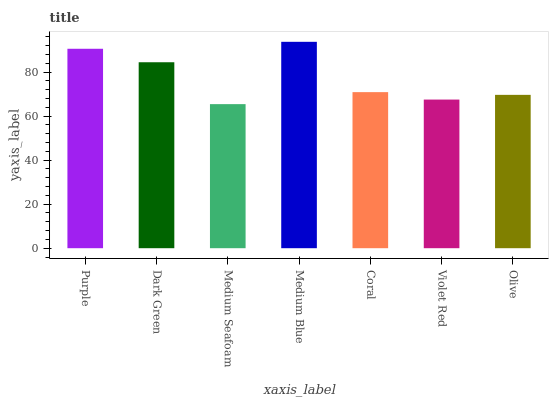Is Medium Seafoam the minimum?
Answer yes or no. Yes. Is Medium Blue the maximum?
Answer yes or no. Yes. Is Dark Green the minimum?
Answer yes or no. No. Is Dark Green the maximum?
Answer yes or no. No. Is Purple greater than Dark Green?
Answer yes or no. Yes. Is Dark Green less than Purple?
Answer yes or no. Yes. Is Dark Green greater than Purple?
Answer yes or no. No. Is Purple less than Dark Green?
Answer yes or no. No. Is Coral the high median?
Answer yes or no. Yes. Is Coral the low median?
Answer yes or no. Yes. Is Purple the high median?
Answer yes or no. No. Is Purple the low median?
Answer yes or no. No. 